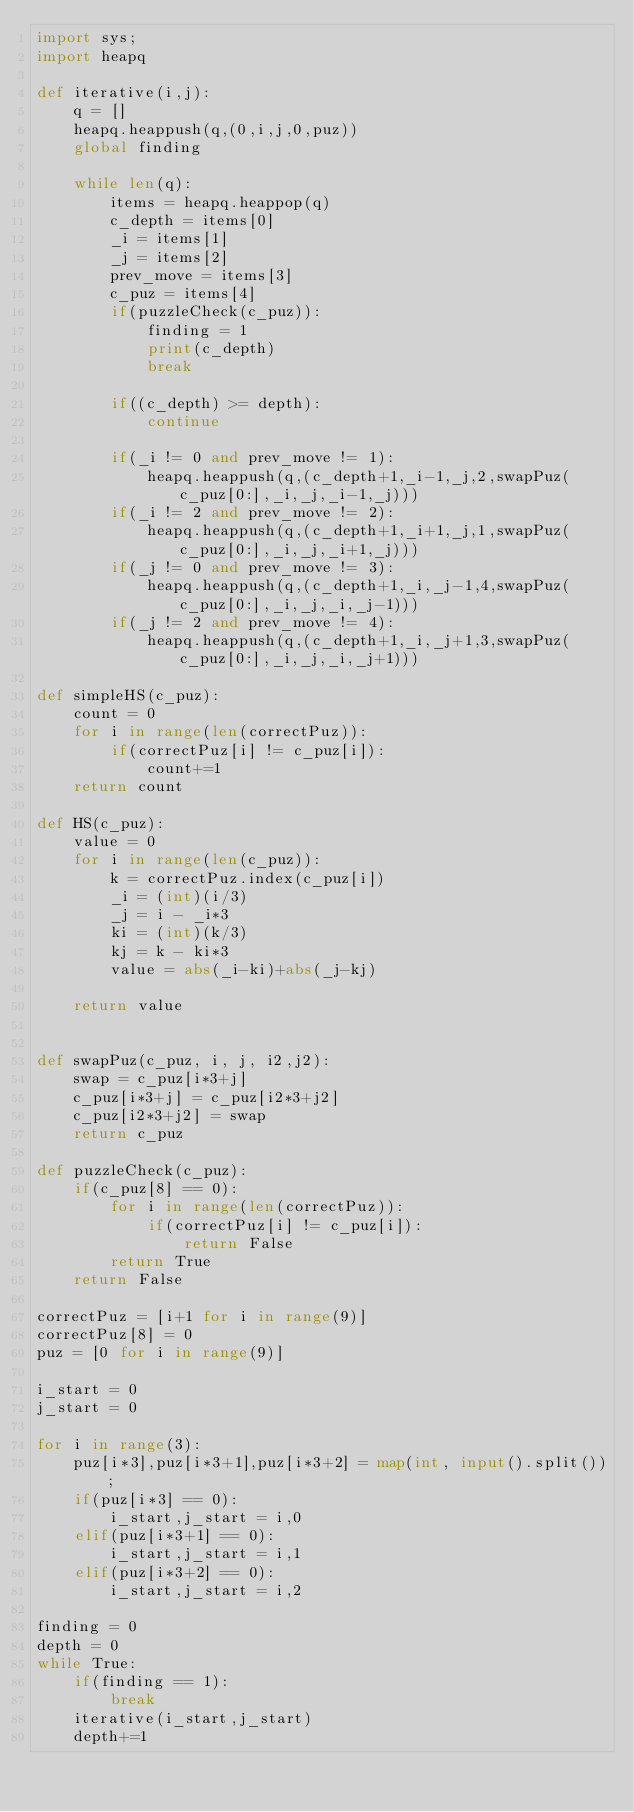<code> <loc_0><loc_0><loc_500><loc_500><_Python_>import sys;
import heapq

def iterative(i,j):
    q = []
    heapq.heappush(q,(0,i,j,0,puz))
    global finding

    while len(q):
        items = heapq.heappop(q)
        c_depth = items[0]
        _i = items[1]
        _j = items[2]
        prev_move = items[3]
        c_puz = items[4]
        if(puzzleCheck(c_puz)):
            finding = 1
            print(c_depth)
            break

        if((c_depth) >= depth):
            continue

        if(_i != 0 and prev_move != 1):
            heapq.heappush(q,(c_depth+1,_i-1,_j,2,swapPuz(c_puz[0:],_i,_j,_i-1,_j)))
        if(_i != 2 and prev_move != 2):
            heapq.heappush(q,(c_depth+1,_i+1,_j,1,swapPuz(c_puz[0:],_i,_j,_i+1,_j)))
        if(_j != 0 and prev_move != 3):
            heapq.heappush(q,(c_depth+1,_i,_j-1,4,swapPuz(c_puz[0:],_i,_j,_i,_j-1)))
        if(_j != 2 and prev_move != 4):
            heapq.heappush(q,(c_depth+1,_i,_j+1,3,swapPuz(c_puz[0:],_i,_j,_i,_j+1)))

def simpleHS(c_puz):
    count = 0
    for i in range(len(correctPuz)):
        if(correctPuz[i] != c_puz[i]):
            count+=1
    return count

def HS(c_puz):
    value = 0
    for i in range(len(c_puz)):
        k = correctPuz.index(c_puz[i])
        _i = (int)(i/3)
        _j = i - _i*3
        ki = (int)(k/3)
        kj = k - ki*3
        value = abs(_i-ki)+abs(_j-kj) 

    return value


def swapPuz(c_puz, i, j, i2,j2):
    swap = c_puz[i*3+j]
    c_puz[i*3+j] = c_puz[i2*3+j2]
    c_puz[i2*3+j2] = swap
    return c_puz

def puzzleCheck(c_puz):
    if(c_puz[8] == 0):
        for i in range(len(correctPuz)):
            if(correctPuz[i] != c_puz[i]):
                return False
        return True
    return False

correctPuz = [i+1 for i in range(9)]
correctPuz[8] = 0
puz = [0 for i in range(9)]

i_start = 0
j_start = 0

for i in range(3):
    puz[i*3],puz[i*3+1],puz[i*3+2] = map(int, input().split());
    if(puz[i*3] == 0):
        i_start,j_start = i,0
    elif(puz[i*3+1] == 0):
        i_start,j_start = i,1
    elif(puz[i*3+2] == 0):
        i_start,j_start = i,2

finding = 0
depth = 0
while True:
    if(finding == 1):
        break
    iterative(i_start,j_start)
    depth+=1



</code> 